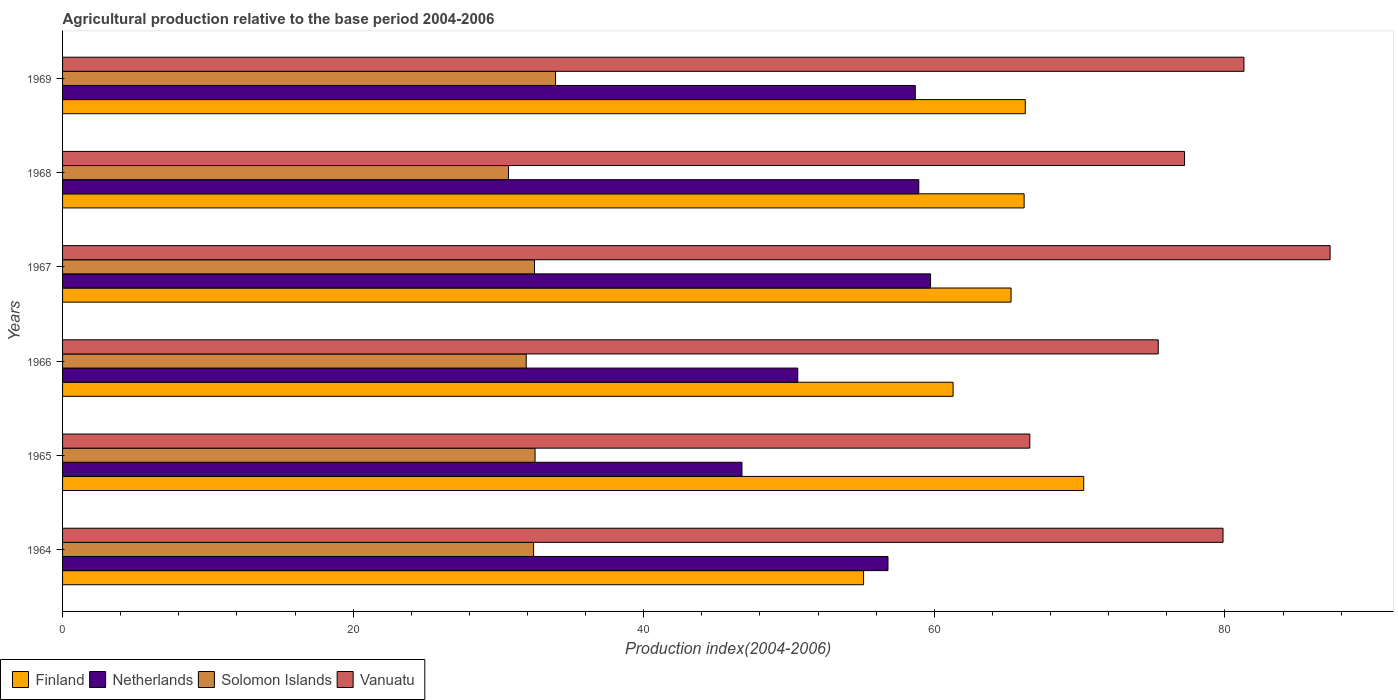How many groups of bars are there?
Your answer should be compact. 6. Are the number of bars on each tick of the Y-axis equal?
Make the answer very short. Yes. What is the label of the 2nd group of bars from the top?
Keep it short and to the point. 1968. In how many cases, is the number of bars for a given year not equal to the number of legend labels?
Provide a succinct answer. 0. What is the agricultural production index in Netherlands in 1968?
Your response must be concise. 58.93. Across all years, what is the maximum agricultural production index in Vanuatu?
Give a very brief answer. 87.24. Across all years, what is the minimum agricultural production index in Solomon Islands?
Give a very brief answer. 30.69. In which year was the agricultural production index in Finland maximum?
Provide a short and direct response. 1965. In which year was the agricultural production index in Solomon Islands minimum?
Your answer should be compact. 1968. What is the total agricultural production index in Solomon Islands in the graph?
Provide a short and direct response. 193.95. What is the difference between the agricultural production index in Netherlands in 1964 and that in 1966?
Provide a short and direct response. 6.21. What is the difference between the agricultural production index in Finland in 1966 and the agricultural production index in Solomon Islands in 1969?
Offer a terse response. 27.36. What is the average agricultural production index in Vanuatu per year?
Provide a short and direct response. 77.94. In the year 1968, what is the difference between the agricultural production index in Finland and agricultural production index in Vanuatu?
Your answer should be compact. -11.04. In how many years, is the agricultural production index in Finland greater than 16 ?
Your answer should be compact. 6. What is the ratio of the agricultural production index in Finland in 1965 to that in 1967?
Provide a short and direct response. 1.08. Is the difference between the agricultural production index in Finland in 1964 and 1965 greater than the difference between the agricultural production index in Vanuatu in 1964 and 1965?
Provide a short and direct response. No. What is the difference between the highest and the second highest agricultural production index in Netherlands?
Give a very brief answer. 0.81. What is the difference between the highest and the lowest agricultural production index in Netherlands?
Make the answer very short. 12.98. In how many years, is the agricultural production index in Solomon Islands greater than the average agricultural production index in Solomon Islands taken over all years?
Your answer should be very brief. 4. What does the 1st bar from the top in 1964 represents?
Keep it short and to the point. Vanuatu. What does the 4th bar from the bottom in 1965 represents?
Your response must be concise. Vanuatu. How many bars are there?
Offer a very short reply. 24. How many years are there in the graph?
Your response must be concise. 6. Does the graph contain any zero values?
Provide a succinct answer. No. How many legend labels are there?
Your answer should be compact. 4. How are the legend labels stacked?
Provide a short and direct response. Horizontal. What is the title of the graph?
Provide a succinct answer. Agricultural production relative to the base period 2004-2006. Does "Iceland" appear as one of the legend labels in the graph?
Keep it short and to the point. No. What is the label or title of the X-axis?
Offer a very short reply. Production index(2004-2006). What is the Production index(2004-2006) of Finland in 1964?
Offer a terse response. 55.13. What is the Production index(2004-2006) of Netherlands in 1964?
Your answer should be compact. 56.81. What is the Production index(2004-2006) in Solomon Islands in 1964?
Your answer should be compact. 32.42. What is the Production index(2004-2006) of Vanuatu in 1964?
Make the answer very short. 79.87. What is the Production index(2004-2006) of Finland in 1965?
Your answer should be compact. 70.28. What is the Production index(2004-2006) of Netherlands in 1965?
Offer a terse response. 46.76. What is the Production index(2004-2006) of Solomon Islands in 1965?
Ensure brevity in your answer.  32.52. What is the Production index(2004-2006) of Vanuatu in 1965?
Keep it short and to the point. 66.57. What is the Production index(2004-2006) in Finland in 1966?
Offer a terse response. 61.29. What is the Production index(2004-2006) of Netherlands in 1966?
Your answer should be very brief. 50.6. What is the Production index(2004-2006) in Solomon Islands in 1966?
Provide a short and direct response. 31.91. What is the Production index(2004-2006) of Vanuatu in 1966?
Keep it short and to the point. 75.41. What is the Production index(2004-2006) of Finland in 1967?
Make the answer very short. 65.28. What is the Production index(2004-2006) of Netherlands in 1967?
Offer a very short reply. 59.74. What is the Production index(2004-2006) of Solomon Islands in 1967?
Your response must be concise. 32.48. What is the Production index(2004-2006) in Vanuatu in 1967?
Provide a succinct answer. 87.24. What is the Production index(2004-2006) of Finland in 1968?
Make the answer very short. 66.18. What is the Production index(2004-2006) of Netherlands in 1968?
Your answer should be very brief. 58.93. What is the Production index(2004-2006) in Solomon Islands in 1968?
Provide a succinct answer. 30.69. What is the Production index(2004-2006) in Vanuatu in 1968?
Your answer should be very brief. 77.22. What is the Production index(2004-2006) of Finland in 1969?
Keep it short and to the point. 66.26. What is the Production index(2004-2006) of Netherlands in 1969?
Offer a terse response. 58.69. What is the Production index(2004-2006) of Solomon Islands in 1969?
Provide a short and direct response. 33.93. What is the Production index(2004-2006) in Vanuatu in 1969?
Offer a very short reply. 81.31. Across all years, what is the maximum Production index(2004-2006) in Finland?
Offer a terse response. 70.28. Across all years, what is the maximum Production index(2004-2006) in Netherlands?
Your response must be concise. 59.74. Across all years, what is the maximum Production index(2004-2006) in Solomon Islands?
Your response must be concise. 33.93. Across all years, what is the maximum Production index(2004-2006) of Vanuatu?
Offer a terse response. 87.24. Across all years, what is the minimum Production index(2004-2006) of Finland?
Keep it short and to the point. 55.13. Across all years, what is the minimum Production index(2004-2006) in Netherlands?
Your answer should be compact. 46.76. Across all years, what is the minimum Production index(2004-2006) of Solomon Islands?
Your response must be concise. 30.69. Across all years, what is the minimum Production index(2004-2006) of Vanuatu?
Ensure brevity in your answer.  66.57. What is the total Production index(2004-2006) in Finland in the graph?
Offer a very short reply. 384.42. What is the total Production index(2004-2006) in Netherlands in the graph?
Keep it short and to the point. 331.53. What is the total Production index(2004-2006) of Solomon Islands in the graph?
Ensure brevity in your answer.  193.95. What is the total Production index(2004-2006) in Vanuatu in the graph?
Your response must be concise. 467.62. What is the difference between the Production index(2004-2006) in Finland in 1964 and that in 1965?
Your answer should be compact. -15.15. What is the difference between the Production index(2004-2006) of Netherlands in 1964 and that in 1965?
Your answer should be compact. 10.05. What is the difference between the Production index(2004-2006) in Solomon Islands in 1964 and that in 1965?
Make the answer very short. -0.1. What is the difference between the Production index(2004-2006) of Vanuatu in 1964 and that in 1965?
Offer a terse response. 13.3. What is the difference between the Production index(2004-2006) in Finland in 1964 and that in 1966?
Make the answer very short. -6.16. What is the difference between the Production index(2004-2006) of Netherlands in 1964 and that in 1966?
Ensure brevity in your answer.  6.21. What is the difference between the Production index(2004-2006) of Solomon Islands in 1964 and that in 1966?
Offer a very short reply. 0.51. What is the difference between the Production index(2004-2006) of Vanuatu in 1964 and that in 1966?
Ensure brevity in your answer.  4.46. What is the difference between the Production index(2004-2006) of Finland in 1964 and that in 1967?
Offer a terse response. -10.15. What is the difference between the Production index(2004-2006) in Netherlands in 1964 and that in 1967?
Your answer should be compact. -2.93. What is the difference between the Production index(2004-2006) of Solomon Islands in 1964 and that in 1967?
Offer a very short reply. -0.06. What is the difference between the Production index(2004-2006) of Vanuatu in 1964 and that in 1967?
Your answer should be very brief. -7.37. What is the difference between the Production index(2004-2006) in Finland in 1964 and that in 1968?
Your response must be concise. -11.05. What is the difference between the Production index(2004-2006) of Netherlands in 1964 and that in 1968?
Offer a terse response. -2.12. What is the difference between the Production index(2004-2006) of Solomon Islands in 1964 and that in 1968?
Make the answer very short. 1.73. What is the difference between the Production index(2004-2006) of Vanuatu in 1964 and that in 1968?
Your response must be concise. 2.65. What is the difference between the Production index(2004-2006) in Finland in 1964 and that in 1969?
Your answer should be compact. -11.13. What is the difference between the Production index(2004-2006) of Netherlands in 1964 and that in 1969?
Give a very brief answer. -1.88. What is the difference between the Production index(2004-2006) in Solomon Islands in 1964 and that in 1969?
Offer a very short reply. -1.51. What is the difference between the Production index(2004-2006) of Vanuatu in 1964 and that in 1969?
Your response must be concise. -1.44. What is the difference between the Production index(2004-2006) of Finland in 1965 and that in 1966?
Offer a very short reply. 8.99. What is the difference between the Production index(2004-2006) in Netherlands in 1965 and that in 1966?
Give a very brief answer. -3.84. What is the difference between the Production index(2004-2006) of Solomon Islands in 1965 and that in 1966?
Your answer should be very brief. 0.61. What is the difference between the Production index(2004-2006) in Vanuatu in 1965 and that in 1966?
Offer a terse response. -8.84. What is the difference between the Production index(2004-2006) of Netherlands in 1965 and that in 1967?
Give a very brief answer. -12.98. What is the difference between the Production index(2004-2006) in Vanuatu in 1965 and that in 1967?
Your answer should be very brief. -20.67. What is the difference between the Production index(2004-2006) of Netherlands in 1965 and that in 1968?
Keep it short and to the point. -12.17. What is the difference between the Production index(2004-2006) of Solomon Islands in 1965 and that in 1968?
Provide a succinct answer. 1.83. What is the difference between the Production index(2004-2006) in Vanuatu in 1965 and that in 1968?
Provide a succinct answer. -10.65. What is the difference between the Production index(2004-2006) of Finland in 1965 and that in 1969?
Your response must be concise. 4.02. What is the difference between the Production index(2004-2006) in Netherlands in 1965 and that in 1969?
Offer a very short reply. -11.93. What is the difference between the Production index(2004-2006) of Solomon Islands in 1965 and that in 1969?
Provide a short and direct response. -1.41. What is the difference between the Production index(2004-2006) of Vanuatu in 1965 and that in 1969?
Offer a very short reply. -14.74. What is the difference between the Production index(2004-2006) of Finland in 1966 and that in 1967?
Keep it short and to the point. -3.99. What is the difference between the Production index(2004-2006) in Netherlands in 1966 and that in 1967?
Provide a short and direct response. -9.14. What is the difference between the Production index(2004-2006) of Solomon Islands in 1966 and that in 1967?
Give a very brief answer. -0.57. What is the difference between the Production index(2004-2006) in Vanuatu in 1966 and that in 1967?
Keep it short and to the point. -11.83. What is the difference between the Production index(2004-2006) of Finland in 1966 and that in 1968?
Your answer should be very brief. -4.89. What is the difference between the Production index(2004-2006) of Netherlands in 1966 and that in 1968?
Give a very brief answer. -8.33. What is the difference between the Production index(2004-2006) of Solomon Islands in 1966 and that in 1968?
Your response must be concise. 1.22. What is the difference between the Production index(2004-2006) in Vanuatu in 1966 and that in 1968?
Provide a short and direct response. -1.81. What is the difference between the Production index(2004-2006) of Finland in 1966 and that in 1969?
Your answer should be compact. -4.97. What is the difference between the Production index(2004-2006) in Netherlands in 1966 and that in 1969?
Your answer should be very brief. -8.09. What is the difference between the Production index(2004-2006) of Solomon Islands in 1966 and that in 1969?
Provide a succinct answer. -2.02. What is the difference between the Production index(2004-2006) of Vanuatu in 1966 and that in 1969?
Provide a succinct answer. -5.9. What is the difference between the Production index(2004-2006) of Finland in 1967 and that in 1968?
Provide a short and direct response. -0.9. What is the difference between the Production index(2004-2006) in Netherlands in 1967 and that in 1968?
Keep it short and to the point. 0.81. What is the difference between the Production index(2004-2006) in Solomon Islands in 1967 and that in 1968?
Make the answer very short. 1.79. What is the difference between the Production index(2004-2006) in Vanuatu in 1967 and that in 1968?
Make the answer very short. 10.02. What is the difference between the Production index(2004-2006) in Finland in 1967 and that in 1969?
Give a very brief answer. -0.98. What is the difference between the Production index(2004-2006) of Netherlands in 1967 and that in 1969?
Provide a succinct answer. 1.05. What is the difference between the Production index(2004-2006) of Solomon Islands in 1967 and that in 1969?
Give a very brief answer. -1.45. What is the difference between the Production index(2004-2006) in Vanuatu in 1967 and that in 1969?
Offer a terse response. 5.93. What is the difference between the Production index(2004-2006) of Finland in 1968 and that in 1969?
Provide a short and direct response. -0.08. What is the difference between the Production index(2004-2006) of Netherlands in 1968 and that in 1969?
Your response must be concise. 0.24. What is the difference between the Production index(2004-2006) in Solomon Islands in 1968 and that in 1969?
Make the answer very short. -3.24. What is the difference between the Production index(2004-2006) of Vanuatu in 1968 and that in 1969?
Offer a very short reply. -4.09. What is the difference between the Production index(2004-2006) in Finland in 1964 and the Production index(2004-2006) in Netherlands in 1965?
Your answer should be compact. 8.37. What is the difference between the Production index(2004-2006) of Finland in 1964 and the Production index(2004-2006) of Solomon Islands in 1965?
Your response must be concise. 22.61. What is the difference between the Production index(2004-2006) in Finland in 1964 and the Production index(2004-2006) in Vanuatu in 1965?
Your answer should be very brief. -11.44. What is the difference between the Production index(2004-2006) in Netherlands in 1964 and the Production index(2004-2006) in Solomon Islands in 1965?
Keep it short and to the point. 24.29. What is the difference between the Production index(2004-2006) in Netherlands in 1964 and the Production index(2004-2006) in Vanuatu in 1965?
Give a very brief answer. -9.76. What is the difference between the Production index(2004-2006) of Solomon Islands in 1964 and the Production index(2004-2006) of Vanuatu in 1965?
Give a very brief answer. -34.15. What is the difference between the Production index(2004-2006) in Finland in 1964 and the Production index(2004-2006) in Netherlands in 1966?
Make the answer very short. 4.53. What is the difference between the Production index(2004-2006) in Finland in 1964 and the Production index(2004-2006) in Solomon Islands in 1966?
Offer a very short reply. 23.22. What is the difference between the Production index(2004-2006) in Finland in 1964 and the Production index(2004-2006) in Vanuatu in 1966?
Offer a terse response. -20.28. What is the difference between the Production index(2004-2006) in Netherlands in 1964 and the Production index(2004-2006) in Solomon Islands in 1966?
Provide a short and direct response. 24.9. What is the difference between the Production index(2004-2006) of Netherlands in 1964 and the Production index(2004-2006) of Vanuatu in 1966?
Your answer should be compact. -18.6. What is the difference between the Production index(2004-2006) in Solomon Islands in 1964 and the Production index(2004-2006) in Vanuatu in 1966?
Provide a short and direct response. -42.99. What is the difference between the Production index(2004-2006) of Finland in 1964 and the Production index(2004-2006) of Netherlands in 1967?
Keep it short and to the point. -4.61. What is the difference between the Production index(2004-2006) in Finland in 1964 and the Production index(2004-2006) in Solomon Islands in 1967?
Offer a very short reply. 22.65. What is the difference between the Production index(2004-2006) in Finland in 1964 and the Production index(2004-2006) in Vanuatu in 1967?
Give a very brief answer. -32.11. What is the difference between the Production index(2004-2006) of Netherlands in 1964 and the Production index(2004-2006) of Solomon Islands in 1967?
Provide a succinct answer. 24.33. What is the difference between the Production index(2004-2006) in Netherlands in 1964 and the Production index(2004-2006) in Vanuatu in 1967?
Offer a terse response. -30.43. What is the difference between the Production index(2004-2006) in Solomon Islands in 1964 and the Production index(2004-2006) in Vanuatu in 1967?
Offer a terse response. -54.82. What is the difference between the Production index(2004-2006) of Finland in 1964 and the Production index(2004-2006) of Solomon Islands in 1968?
Your answer should be very brief. 24.44. What is the difference between the Production index(2004-2006) in Finland in 1964 and the Production index(2004-2006) in Vanuatu in 1968?
Provide a short and direct response. -22.09. What is the difference between the Production index(2004-2006) in Netherlands in 1964 and the Production index(2004-2006) in Solomon Islands in 1968?
Give a very brief answer. 26.12. What is the difference between the Production index(2004-2006) of Netherlands in 1964 and the Production index(2004-2006) of Vanuatu in 1968?
Your response must be concise. -20.41. What is the difference between the Production index(2004-2006) in Solomon Islands in 1964 and the Production index(2004-2006) in Vanuatu in 1968?
Provide a short and direct response. -44.8. What is the difference between the Production index(2004-2006) of Finland in 1964 and the Production index(2004-2006) of Netherlands in 1969?
Make the answer very short. -3.56. What is the difference between the Production index(2004-2006) in Finland in 1964 and the Production index(2004-2006) in Solomon Islands in 1969?
Ensure brevity in your answer.  21.2. What is the difference between the Production index(2004-2006) of Finland in 1964 and the Production index(2004-2006) of Vanuatu in 1969?
Offer a very short reply. -26.18. What is the difference between the Production index(2004-2006) in Netherlands in 1964 and the Production index(2004-2006) in Solomon Islands in 1969?
Give a very brief answer. 22.88. What is the difference between the Production index(2004-2006) in Netherlands in 1964 and the Production index(2004-2006) in Vanuatu in 1969?
Offer a terse response. -24.5. What is the difference between the Production index(2004-2006) of Solomon Islands in 1964 and the Production index(2004-2006) of Vanuatu in 1969?
Your answer should be compact. -48.89. What is the difference between the Production index(2004-2006) in Finland in 1965 and the Production index(2004-2006) in Netherlands in 1966?
Provide a short and direct response. 19.68. What is the difference between the Production index(2004-2006) in Finland in 1965 and the Production index(2004-2006) in Solomon Islands in 1966?
Your answer should be compact. 38.37. What is the difference between the Production index(2004-2006) in Finland in 1965 and the Production index(2004-2006) in Vanuatu in 1966?
Your answer should be very brief. -5.13. What is the difference between the Production index(2004-2006) in Netherlands in 1965 and the Production index(2004-2006) in Solomon Islands in 1966?
Ensure brevity in your answer.  14.85. What is the difference between the Production index(2004-2006) of Netherlands in 1965 and the Production index(2004-2006) of Vanuatu in 1966?
Your answer should be very brief. -28.65. What is the difference between the Production index(2004-2006) of Solomon Islands in 1965 and the Production index(2004-2006) of Vanuatu in 1966?
Keep it short and to the point. -42.89. What is the difference between the Production index(2004-2006) in Finland in 1965 and the Production index(2004-2006) in Netherlands in 1967?
Give a very brief answer. 10.54. What is the difference between the Production index(2004-2006) of Finland in 1965 and the Production index(2004-2006) of Solomon Islands in 1967?
Make the answer very short. 37.8. What is the difference between the Production index(2004-2006) of Finland in 1965 and the Production index(2004-2006) of Vanuatu in 1967?
Ensure brevity in your answer.  -16.96. What is the difference between the Production index(2004-2006) of Netherlands in 1965 and the Production index(2004-2006) of Solomon Islands in 1967?
Offer a terse response. 14.28. What is the difference between the Production index(2004-2006) of Netherlands in 1965 and the Production index(2004-2006) of Vanuatu in 1967?
Your response must be concise. -40.48. What is the difference between the Production index(2004-2006) in Solomon Islands in 1965 and the Production index(2004-2006) in Vanuatu in 1967?
Ensure brevity in your answer.  -54.72. What is the difference between the Production index(2004-2006) of Finland in 1965 and the Production index(2004-2006) of Netherlands in 1968?
Your answer should be very brief. 11.35. What is the difference between the Production index(2004-2006) in Finland in 1965 and the Production index(2004-2006) in Solomon Islands in 1968?
Provide a succinct answer. 39.59. What is the difference between the Production index(2004-2006) of Finland in 1965 and the Production index(2004-2006) of Vanuatu in 1968?
Make the answer very short. -6.94. What is the difference between the Production index(2004-2006) of Netherlands in 1965 and the Production index(2004-2006) of Solomon Islands in 1968?
Make the answer very short. 16.07. What is the difference between the Production index(2004-2006) of Netherlands in 1965 and the Production index(2004-2006) of Vanuatu in 1968?
Offer a very short reply. -30.46. What is the difference between the Production index(2004-2006) in Solomon Islands in 1965 and the Production index(2004-2006) in Vanuatu in 1968?
Offer a very short reply. -44.7. What is the difference between the Production index(2004-2006) of Finland in 1965 and the Production index(2004-2006) of Netherlands in 1969?
Offer a terse response. 11.59. What is the difference between the Production index(2004-2006) in Finland in 1965 and the Production index(2004-2006) in Solomon Islands in 1969?
Ensure brevity in your answer.  36.35. What is the difference between the Production index(2004-2006) of Finland in 1965 and the Production index(2004-2006) of Vanuatu in 1969?
Provide a short and direct response. -11.03. What is the difference between the Production index(2004-2006) in Netherlands in 1965 and the Production index(2004-2006) in Solomon Islands in 1969?
Your response must be concise. 12.83. What is the difference between the Production index(2004-2006) in Netherlands in 1965 and the Production index(2004-2006) in Vanuatu in 1969?
Your response must be concise. -34.55. What is the difference between the Production index(2004-2006) in Solomon Islands in 1965 and the Production index(2004-2006) in Vanuatu in 1969?
Offer a terse response. -48.79. What is the difference between the Production index(2004-2006) in Finland in 1966 and the Production index(2004-2006) in Netherlands in 1967?
Provide a succinct answer. 1.55. What is the difference between the Production index(2004-2006) in Finland in 1966 and the Production index(2004-2006) in Solomon Islands in 1967?
Ensure brevity in your answer.  28.81. What is the difference between the Production index(2004-2006) of Finland in 1966 and the Production index(2004-2006) of Vanuatu in 1967?
Your answer should be compact. -25.95. What is the difference between the Production index(2004-2006) in Netherlands in 1966 and the Production index(2004-2006) in Solomon Islands in 1967?
Provide a succinct answer. 18.12. What is the difference between the Production index(2004-2006) in Netherlands in 1966 and the Production index(2004-2006) in Vanuatu in 1967?
Provide a short and direct response. -36.64. What is the difference between the Production index(2004-2006) of Solomon Islands in 1966 and the Production index(2004-2006) of Vanuatu in 1967?
Ensure brevity in your answer.  -55.33. What is the difference between the Production index(2004-2006) in Finland in 1966 and the Production index(2004-2006) in Netherlands in 1968?
Provide a succinct answer. 2.36. What is the difference between the Production index(2004-2006) of Finland in 1966 and the Production index(2004-2006) of Solomon Islands in 1968?
Provide a short and direct response. 30.6. What is the difference between the Production index(2004-2006) in Finland in 1966 and the Production index(2004-2006) in Vanuatu in 1968?
Ensure brevity in your answer.  -15.93. What is the difference between the Production index(2004-2006) in Netherlands in 1966 and the Production index(2004-2006) in Solomon Islands in 1968?
Provide a short and direct response. 19.91. What is the difference between the Production index(2004-2006) in Netherlands in 1966 and the Production index(2004-2006) in Vanuatu in 1968?
Provide a succinct answer. -26.62. What is the difference between the Production index(2004-2006) of Solomon Islands in 1966 and the Production index(2004-2006) of Vanuatu in 1968?
Provide a succinct answer. -45.31. What is the difference between the Production index(2004-2006) in Finland in 1966 and the Production index(2004-2006) in Netherlands in 1969?
Offer a terse response. 2.6. What is the difference between the Production index(2004-2006) of Finland in 1966 and the Production index(2004-2006) of Solomon Islands in 1969?
Ensure brevity in your answer.  27.36. What is the difference between the Production index(2004-2006) in Finland in 1966 and the Production index(2004-2006) in Vanuatu in 1969?
Offer a terse response. -20.02. What is the difference between the Production index(2004-2006) in Netherlands in 1966 and the Production index(2004-2006) in Solomon Islands in 1969?
Keep it short and to the point. 16.67. What is the difference between the Production index(2004-2006) in Netherlands in 1966 and the Production index(2004-2006) in Vanuatu in 1969?
Ensure brevity in your answer.  -30.71. What is the difference between the Production index(2004-2006) of Solomon Islands in 1966 and the Production index(2004-2006) of Vanuatu in 1969?
Ensure brevity in your answer.  -49.4. What is the difference between the Production index(2004-2006) of Finland in 1967 and the Production index(2004-2006) of Netherlands in 1968?
Keep it short and to the point. 6.35. What is the difference between the Production index(2004-2006) in Finland in 1967 and the Production index(2004-2006) in Solomon Islands in 1968?
Make the answer very short. 34.59. What is the difference between the Production index(2004-2006) of Finland in 1967 and the Production index(2004-2006) of Vanuatu in 1968?
Provide a succinct answer. -11.94. What is the difference between the Production index(2004-2006) in Netherlands in 1967 and the Production index(2004-2006) in Solomon Islands in 1968?
Offer a terse response. 29.05. What is the difference between the Production index(2004-2006) of Netherlands in 1967 and the Production index(2004-2006) of Vanuatu in 1968?
Offer a very short reply. -17.48. What is the difference between the Production index(2004-2006) of Solomon Islands in 1967 and the Production index(2004-2006) of Vanuatu in 1968?
Provide a short and direct response. -44.74. What is the difference between the Production index(2004-2006) of Finland in 1967 and the Production index(2004-2006) of Netherlands in 1969?
Offer a terse response. 6.59. What is the difference between the Production index(2004-2006) of Finland in 1967 and the Production index(2004-2006) of Solomon Islands in 1969?
Keep it short and to the point. 31.35. What is the difference between the Production index(2004-2006) in Finland in 1967 and the Production index(2004-2006) in Vanuatu in 1969?
Make the answer very short. -16.03. What is the difference between the Production index(2004-2006) in Netherlands in 1967 and the Production index(2004-2006) in Solomon Islands in 1969?
Keep it short and to the point. 25.81. What is the difference between the Production index(2004-2006) in Netherlands in 1967 and the Production index(2004-2006) in Vanuatu in 1969?
Keep it short and to the point. -21.57. What is the difference between the Production index(2004-2006) of Solomon Islands in 1967 and the Production index(2004-2006) of Vanuatu in 1969?
Ensure brevity in your answer.  -48.83. What is the difference between the Production index(2004-2006) of Finland in 1968 and the Production index(2004-2006) of Netherlands in 1969?
Provide a short and direct response. 7.49. What is the difference between the Production index(2004-2006) in Finland in 1968 and the Production index(2004-2006) in Solomon Islands in 1969?
Offer a terse response. 32.25. What is the difference between the Production index(2004-2006) in Finland in 1968 and the Production index(2004-2006) in Vanuatu in 1969?
Your answer should be very brief. -15.13. What is the difference between the Production index(2004-2006) of Netherlands in 1968 and the Production index(2004-2006) of Vanuatu in 1969?
Offer a very short reply. -22.38. What is the difference between the Production index(2004-2006) of Solomon Islands in 1968 and the Production index(2004-2006) of Vanuatu in 1969?
Keep it short and to the point. -50.62. What is the average Production index(2004-2006) in Finland per year?
Ensure brevity in your answer.  64.07. What is the average Production index(2004-2006) in Netherlands per year?
Offer a terse response. 55.26. What is the average Production index(2004-2006) of Solomon Islands per year?
Provide a succinct answer. 32.33. What is the average Production index(2004-2006) of Vanuatu per year?
Make the answer very short. 77.94. In the year 1964, what is the difference between the Production index(2004-2006) in Finland and Production index(2004-2006) in Netherlands?
Offer a terse response. -1.68. In the year 1964, what is the difference between the Production index(2004-2006) of Finland and Production index(2004-2006) of Solomon Islands?
Ensure brevity in your answer.  22.71. In the year 1964, what is the difference between the Production index(2004-2006) in Finland and Production index(2004-2006) in Vanuatu?
Your answer should be compact. -24.74. In the year 1964, what is the difference between the Production index(2004-2006) of Netherlands and Production index(2004-2006) of Solomon Islands?
Keep it short and to the point. 24.39. In the year 1964, what is the difference between the Production index(2004-2006) of Netherlands and Production index(2004-2006) of Vanuatu?
Make the answer very short. -23.06. In the year 1964, what is the difference between the Production index(2004-2006) of Solomon Islands and Production index(2004-2006) of Vanuatu?
Keep it short and to the point. -47.45. In the year 1965, what is the difference between the Production index(2004-2006) of Finland and Production index(2004-2006) of Netherlands?
Keep it short and to the point. 23.52. In the year 1965, what is the difference between the Production index(2004-2006) of Finland and Production index(2004-2006) of Solomon Islands?
Provide a succinct answer. 37.76. In the year 1965, what is the difference between the Production index(2004-2006) of Finland and Production index(2004-2006) of Vanuatu?
Ensure brevity in your answer.  3.71. In the year 1965, what is the difference between the Production index(2004-2006) in Netherlands and Production index(2004-2006) in Solomon Islands?
Offer a very short reply. 14.24. In the year 1965, what is the difference between the Production index(2004-2006) in Netherlands and Production index(2004-2006) in Vanuatu?
Offer a very short reply. -19.81. In the year 1965, what is the difference between the Production index(2004-2006) of Solomon Islands and Production index(2004-2006) of Vanuatu?
Give a very brief answer. -34.05. In the year 1966, what is the difference between the Production index(2004-2006) in Finland and Production index(2004-2006) in Netherlands?
Give a very brief answer. 10.69. In the year 1966, what is the difference between the Production index(2004-2006) of Finland and Production index(2004-2006) of Solomon Islands?
Offer a very short reply. 29.38. In the year 1966, what is the difference between the Production index(2004-2006) of Finland and Production index(2004-2006) of Vanuatu?
Give a very brief answer. -14.12. In the year 1966, what is the difference between the Production index(2004-2006) of Netherlands and Production index(2004-2006) of Solomon Islands?
Your response must be concise. 18.69. In the year 1966, what is the difference between the Production index(2004-2006) of Netherlands and Production index(2004-2006) of Vanuatu?
Offer a very short reply. -24.81. In the year 1966, what is the difference between the Production index(2004-2006) in Solomon Islands and Production index(2004-2006) in Vanuatu?
Provide a succinct answer. -43.5. In the year 1967, what is the difference between the Production index(2004-2006) of Finland and Production index(2004-2006) of Netherlands?
Keep it short and to the point. 5.54. In the year 1967, what is the difference between the Production index(2004-2006) of Finland and Production index(2004-2006) of Solomon Islands?
Keep it short and to the point. 32.8. In the year 1967, what is the difference between the Production index(2004-2006) in Finland and Production index(2004-2006) in Vanuatu?
Provide a short and direct response. -21.96. In the year 1967, what is the difference between the Production index(2004-2006) of Netherlands and Production index(2004-2006) of Solomon Islands?
Provide a short and direct response. 27.26. In the year 1967, what is the difference between the Production index(2004-2006) in Netherlands and Production index(2004-2006) in Vanuatu?
Offer a terse response. -27.5. In the year 1967, what is the difference between the Production index(2004-2006) in Solomon Islands and Production index(2004-2006) in Vanuatu?
Give a very brief answer. -54.76. In the year 1968, what is the difference between the Production index(2004-2006) of Finland and Production index(2004-2006) of Netherlands?
Keep it short and to the point. 7.25. In the year 1968, what is the difference between the Production index(2004-2006) in Finland and Production index(2004-2006) in Solomon Islands?
Your response must be concise. 35.49. In the year 1968, what is the difference between the Production index(2004-2006) of Finland and Production index(2004-2006) of Vanuatu?
Keep it short and to the point. -11.04. In the year 1968, what is the difference between the Production index(2004-2006) of Netherlands and Production index(2004-2006) of Solomon Islands?
Provide a succinct answer. 28.24. In the year 1968, what is the difference between the Production index(2004-2006) of Netherlands and Production index(2004-2006) of Vanuatu?
Your answer should be compact. -18.29. In the year 1968, what is the difference between the Production index(2004-2006) of Solomon Islands and Production index(2004-2006) of Vanuatu?
Your answer should be compact. -46.53. In the year 1969, what is the difference between the Production index(2004-2006) of Finland and Production index(2004-2006) of Netherlands?
Make the answer very short. 7.57. In the year 1969, what is the difference between the Production index(2004-2006) in Finland and Production index(2004-2006) in Solomon Islands?
Make the answer very short. 32.33. In the year 1969, what is the difference between the Production index(2004-2006) of Finland and Production index(2004-2006) of Vanuatu?
Give a very brief answer. -15.05. In the year 1969, what is the difference between the Production index(2004-2006) of Netherlands and Production index(2004-2006) of Solomon Islands?
Give a very brief answer. 24.76. In the year 1969, what is the difference between the Production index(2004-2006) of Netherlands and Production index(2004-2006) of Vanuatu?
Provide a short and direct response. -22.62. In the year 1969, what is the difference between the Production index(2004-2006) of Solomon Islands and Production index(2004-2006) of Vanuatu?
Provide a succinct answer. -47.38. What is the ratio of the Production index(2004-2006) in Finland in 1964 to that in 1965?
Your answer should be very brief. 0.78. What is the ratio of the Production index(2004-2006) of Netherlands in 1964 to that in 1965?
Offer a terse response. 1.21. What is the ratio of the Production index(2004-2006) in Solomon Islands in 1964 to that in 1965?
Provide a succinct answer. 1. What is the ratio of the Production index(2004-2006) of Vanuatu in 1964 to that in 1965?
Offer a terse response. 1.2. What is the ratio of the Production index(2004-2006) of Finland in 1964 to that in 1966?
Your answer should be compact. 0.9. What is the ratio of the Production index(2004-2006) in Netherlands in 1964 to that in 1966?
Offer a terse response. 1.12. What is the ratio of the Production index(2004-2006) of Vanuatu in 1964 to that in 1966?
Provide a succinct answer. 1.06. What is the ratio of the Production index(2004-2006) of Finland in 1964 to that in 1967?
Offer a terse response. 0.84. What is the ratio of the Production index(2004-2006) of Netherlands in 1964 to that in 1967?
Provide a short and direct response. 0.95. What is the ratio of the Production index(2004-2006) in Solomon Islands in 1964 to that in 1967?
Offer a terse response. 1. What is the ratio of the Production index(2004-2006) of Vanuatu in 1964 to that in 1967?
Your response must be concise. 0.92. What is the ratio of the Production index(2004-2006) in Finland in 1964 to that in 1968?
Keep it short and to the point. 0.83. What is the ratio of the Production index(2004-2006) in Netherlands in 1964 to that in 1968?
Your response must be concise. 0.96. What is the ratio of the Production index(2004-2006) in Solomon Islands in 1964 to that in 1968?
Provide a short and direct response. 1.06. What is the ratio of the Production index(2004-2006) in Vanuatu in 1964 to that in 1968?
Provide a short and direct response. 1.03. What is the ratio of the Production index(2004-2006) in Finland in 1964 to that in 1969?
Keep it short and to the point. 0.83. What is the ratio of the Production index(2004-2006) of Solomon Islands in 1964 to that in 1969?
Provide a short and direct response. 0.96. What is the ratio of the Production index(2004-2006) of Vanuatu in 1964 to that in 1969?
Ensure brevity in your answer.  0.98. What is the ratio of the Production index(2004-2006) of Finland in 1965 to that in 1966?
Provide a short and direct response. 1.15. What is the ratio of the Production index(2004-2006) in Netherlands in 1965 to that in 1966?
Provide a short and direct response. 0.92. What is the ratio of the Production index(2004-2006) in Solomon Islands in 1965 to that in 1966?
Offer a very short reply. 1.02. What is the ratio of the Production index(2004-2006) in Vanuatu in 1965 to that in 1966?
Your response must be concise. 0.88. What is the ratio of the Production index(2004-2006) of Finland in 1965 to that in 1967?
Your answer should be very brief. 1.08. What is the ratio of the Production index(2004-2006) in Netherlands in 1965 to that in 1967?
Provide a succinct answer. 0.78. What is the ratio of the Production index(2004-2006) in Vanuatu in 1965 to that in 1967?
Keep it short and to the point. 0.76. What is the ratio of the Production index(2004-2006) of Finland in 1965 to that in 1968?
Make the answer very short. 1.06. What is the ratio of the Production index(2004-2006) of Netherlands in 1965 to that in 1968?
Your answer should be very brief. 0.79. What is the ratio of the Production index(2004-2006) in Solomon Islands in 1965 to that in 1968?
Give a very brief answer. 1.06. What is the ratio of the Production index(2004-2006) in Vanuatu in 1965 to that in 1968?
Provide a succinct answer. 0.86. What is the ratio of the Production index(2004-2006) in Finland in 1965 to that in 1969?
Make the answer very short. 1.06. What is the ratio of the Production index(2004-2006) in Netherlands in 1965 to that in 1969?
Offer a very short reply. 0.8. What is the ratio of the Production index(2004-2006) of Solomon Islands in 1965 to that in 1969?
Provide a short and direct response. 0.96. What is the ratio of the Production index(2004-2006) in Vanuatu in 1965 to that in 1969?
Offer a very short reply. 0.82. What is the ratio of the Production index(2004-2006) in Finland in 1966 to that in 1967?
Your answer should be very brief. 0.94. What is the ratio of the Production index(2004-2006) in Netherlands in 1966 to that in 1967?
Offer a very short reply. 0.85. What is the ratio of the Production index(2004-2006) of Solomon Islands in 1966 to that in 1967?
Your answer should be very brief. 0.98. What is the ratio of the Production index(2004-2006) of Vanuatu in 1966 to that in 1967?
Ensure brevity in your answer.  0.86. What is the ratio of the Production index(2004-2006) in Finland in 1966 to that in 1968?
Give a very brief answer. 0.93. What is the ratio of the Production index(2004-2006) in Netherlands in 1966 to that in 1968?
Your answer should be compact. 0.86. What is the ratio of the Production index(2004-2006) of Solomon Islands in 1966 to that in 1968?
Your answer should be very brief. 1.04. What is the ratio of the Production index(2004-2006) in Vanuatu in 1966 to that in 1968?
Your answer should be very brief. 0.98. What is the ratio of the Production index(2004-2006) of Finland in 1966 to that in 1969?
Give a very brief answer. 0.93. What is the ratio of the Production index(2004-2006) of Netherlands in 1966 to that in 1969?
Your response must be concise. 0.86. What is the ratio of the Production index(2004-2006) of Solomon Islands in 1966 to that in 1969?
Offer a very short reply. 0.94. What is the ratio of the Production index(2004-2006) in Vanuatu in 1966 to that in 1969?
Make the answer very short. 0.93. What is the ratio of the Production index(2004-2006) in Finland in 1967 to that in 1968?
Offer a very short reply. 0.99. What is the ratio of the Production index(2004-2006) in Netherlands in 1967 to that in 1968?
Offer a very short reply. 1.01. What is the ratio of the Production index(2004-2006) in Solomon Islands in 1967 to that in 1968?
Make the answer very short. 1.06. What is the ratio of the Production index(2004-2006) of Vanuatu in 1967 to that in 1968?
Your answer should be very brief. 1.13. What is the ratio of the Production index(2004-2006) of Finland in 1967 to that in 1969?
Make the answer very short. 0.99. What is the ratio of the Production index(2004-2006) of Netherlands in 1967 to that in 1969?
Provide a short and direct response. 1.02. What is the ratio of the Production index(2004-2006) of Solomon Islands in 1967 to that in 1969?
Keep it short and to the point. 0.96. What is the ratio of the Production index(2004-2006) in Vanuatu in 1967 to that in 1969?
Your answer should be compact. 1.07. What is the ratio of the Production index(2004-2006) of Netherlands in 1968 to that in 1969?
Keep it short and to the point. 1. What is the ratio of the Production index(2004-2006) in Solomon Islands in 1968 to that in 1969?
Ensure brevity in your answer.  0.9. What is the ratio of the Production index(2004-2006) of Vanuatu in 1968 to that in 1969?
Your answer should be very brief. 0.95. What is the difference between the highest and the second highest Production index(2004-2006) of Finland?
Offer a terse response. 4.02. What is the difference between the highest and the second highest Production index(2004-2006) in Netherlands?
Keep it short and to the point. 0.81. What is the difference between the highest and the second highest Production index(2004-2006) of Solomon Islands?
Offer a terse response. 1.41. What is the difference between the highest and the second highest Production index(2004-2006) in Vanuatu?
Your response must be concise. 5.93. What is the difference between the highest and the lowest Production index(2004-2006) of Finland?
Keep it short and to the point. 15.15. What is the difference between the highest and the lowest Production index(2004-2006) of Netherlands?
Give a very brief answer. 12.98. What is the difference between the highest and the lowest Production index(2004-2006) of Solomon Islands?
Provide a succinct answer. 3.24. What is the difference between the highest and the lowest Production index(2004-2006) in Vanuatu?
Make the answer very short. 20.67. 